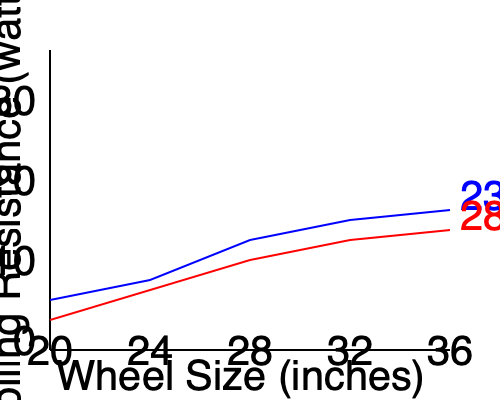Based on the data plot showing the relationship between wheel size, tire width, and rolling resistance, which combination would likely provide the lowest rolling resistance for a high-performance road bike? How might this impact the market positioning of traditional road bike designs? To answer this question, we need to analyze the graph and understand the relationships between the variables:

1. The x-axis represents wheel size in inches, ranging from 20" to 36".
2. The y-axis represents rolling resistance in watts (lower is better).
3. Two lines are shown: blue for 23mm tire width and red for 28mm tire width.

Step-by-step analysis:
1. As wheel size increases, rolling resistance generally decreases for both tire widths.
2. The 23mm tire (blue line) consistently shows lower rolling resistance than the 28mm tire (red line) across all wheel sizes.
3. The greatest difference in rolling resistance between the two tire widths is at smaller wheel sizes.
4. The lines begin to converge as wheel size increases, suggesting diminishing returns for larger wheels.
5. The lowest point on the graph, indicating the least rolling resistance, is at the largest wheel size (36") with the 23mm tire width.

Impact on market positioning:
1. This data suggests that larger wheels with narrower tires provide the lowest rolling resistance, which could lead to faster speeds and improved efficiency.
2. Traditional road bike designs often use 700c wheels (approximately 29") with 23-25mm tires. This data indicates that even larger wheels could provide further benefits.
3. The trend towards wider tires (28mm and above) in recent years may need to be re-evaluated in light of this data, as it shows narrower tires having an advantage in terms of rolling resistance.
4. Bike manufacturers focusing on traditional designs may need to consider developing models with larger wheels to remain competitive in terms of performance.
5. However, other factors such as weight, aerodynamics, and handling must also be considered in overall bike design and marketing strategy.
Answer: 36" wheels with 23mm tires; challenges traditional designs, potentially disrupting the market with larger wheel sizes and narrower tires for performance road bikes. 